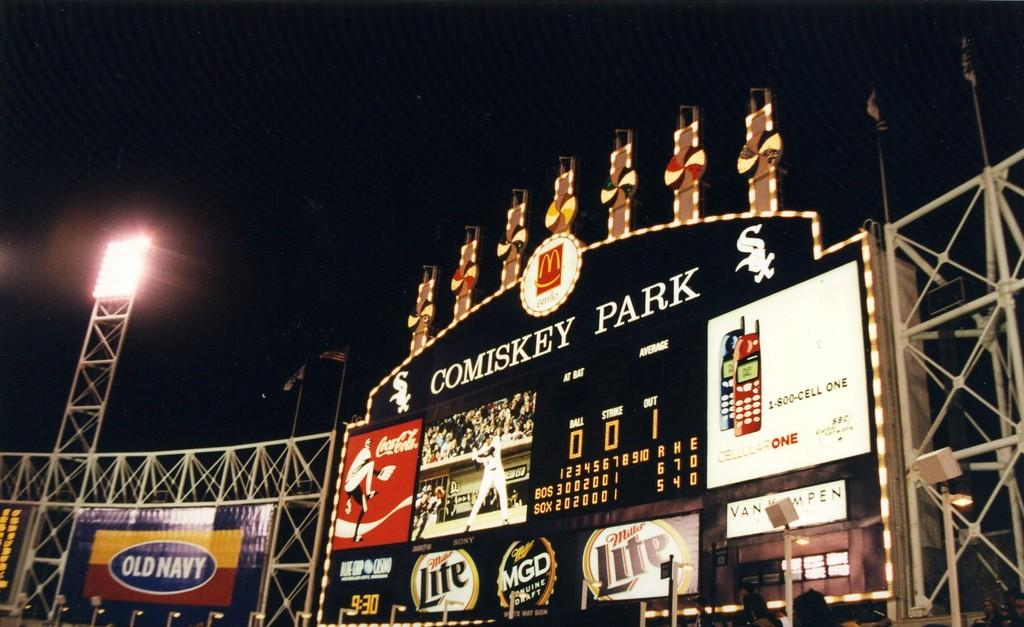<image>
Present a compact description of the photo's key features. A baseball stadium at night with the lights on with large billboard saying Cominsky Park and with many advertisements being displayed. 